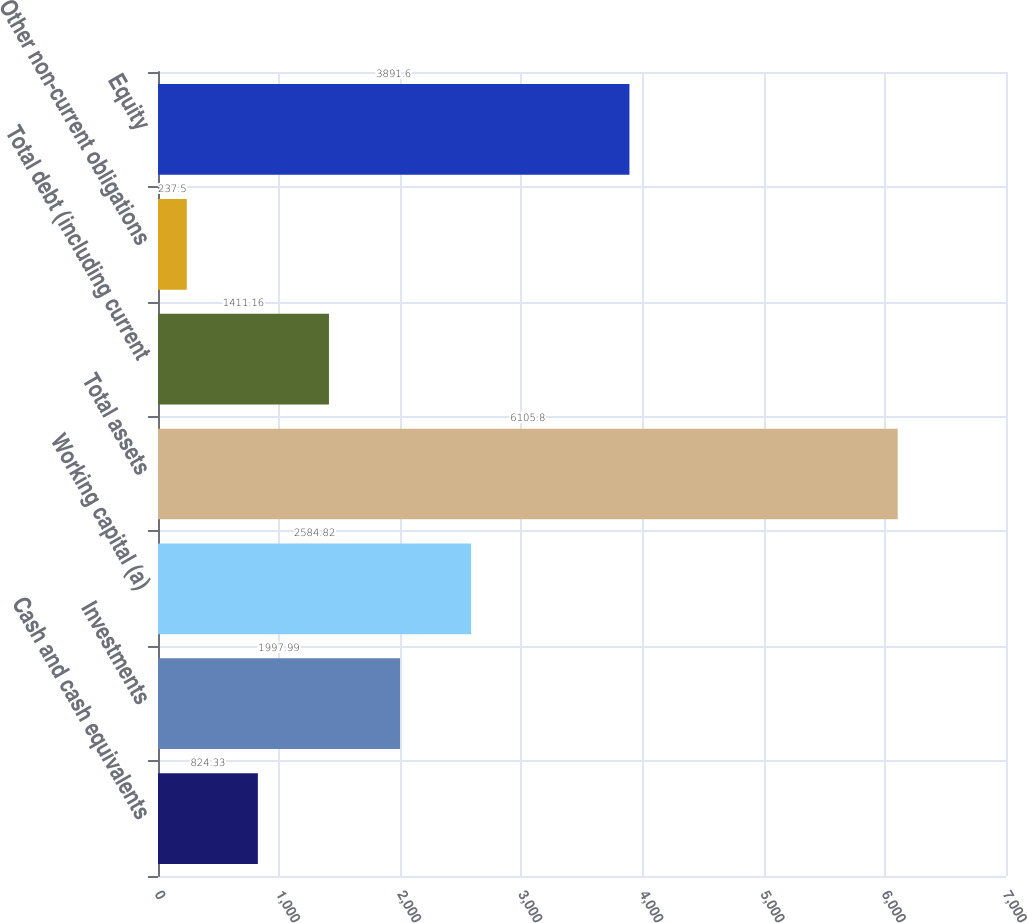<chart> <loc_0><loc_0><loc_500><loc_500><bar_chart><fcel>Cash and cash equivalents<fcel>Investments<fcel>Working capital (a)<fcel>Total assets<fcel>Total debt (including current<fcel>Other non-current obligations<fcel>Equity<nl><fcel>824.33<fcel>1997.99<fcel>2584.82<fcel>6105.8<fcel>1411.16<fcel>237.5<fcel>3891.6<nl></chart> 